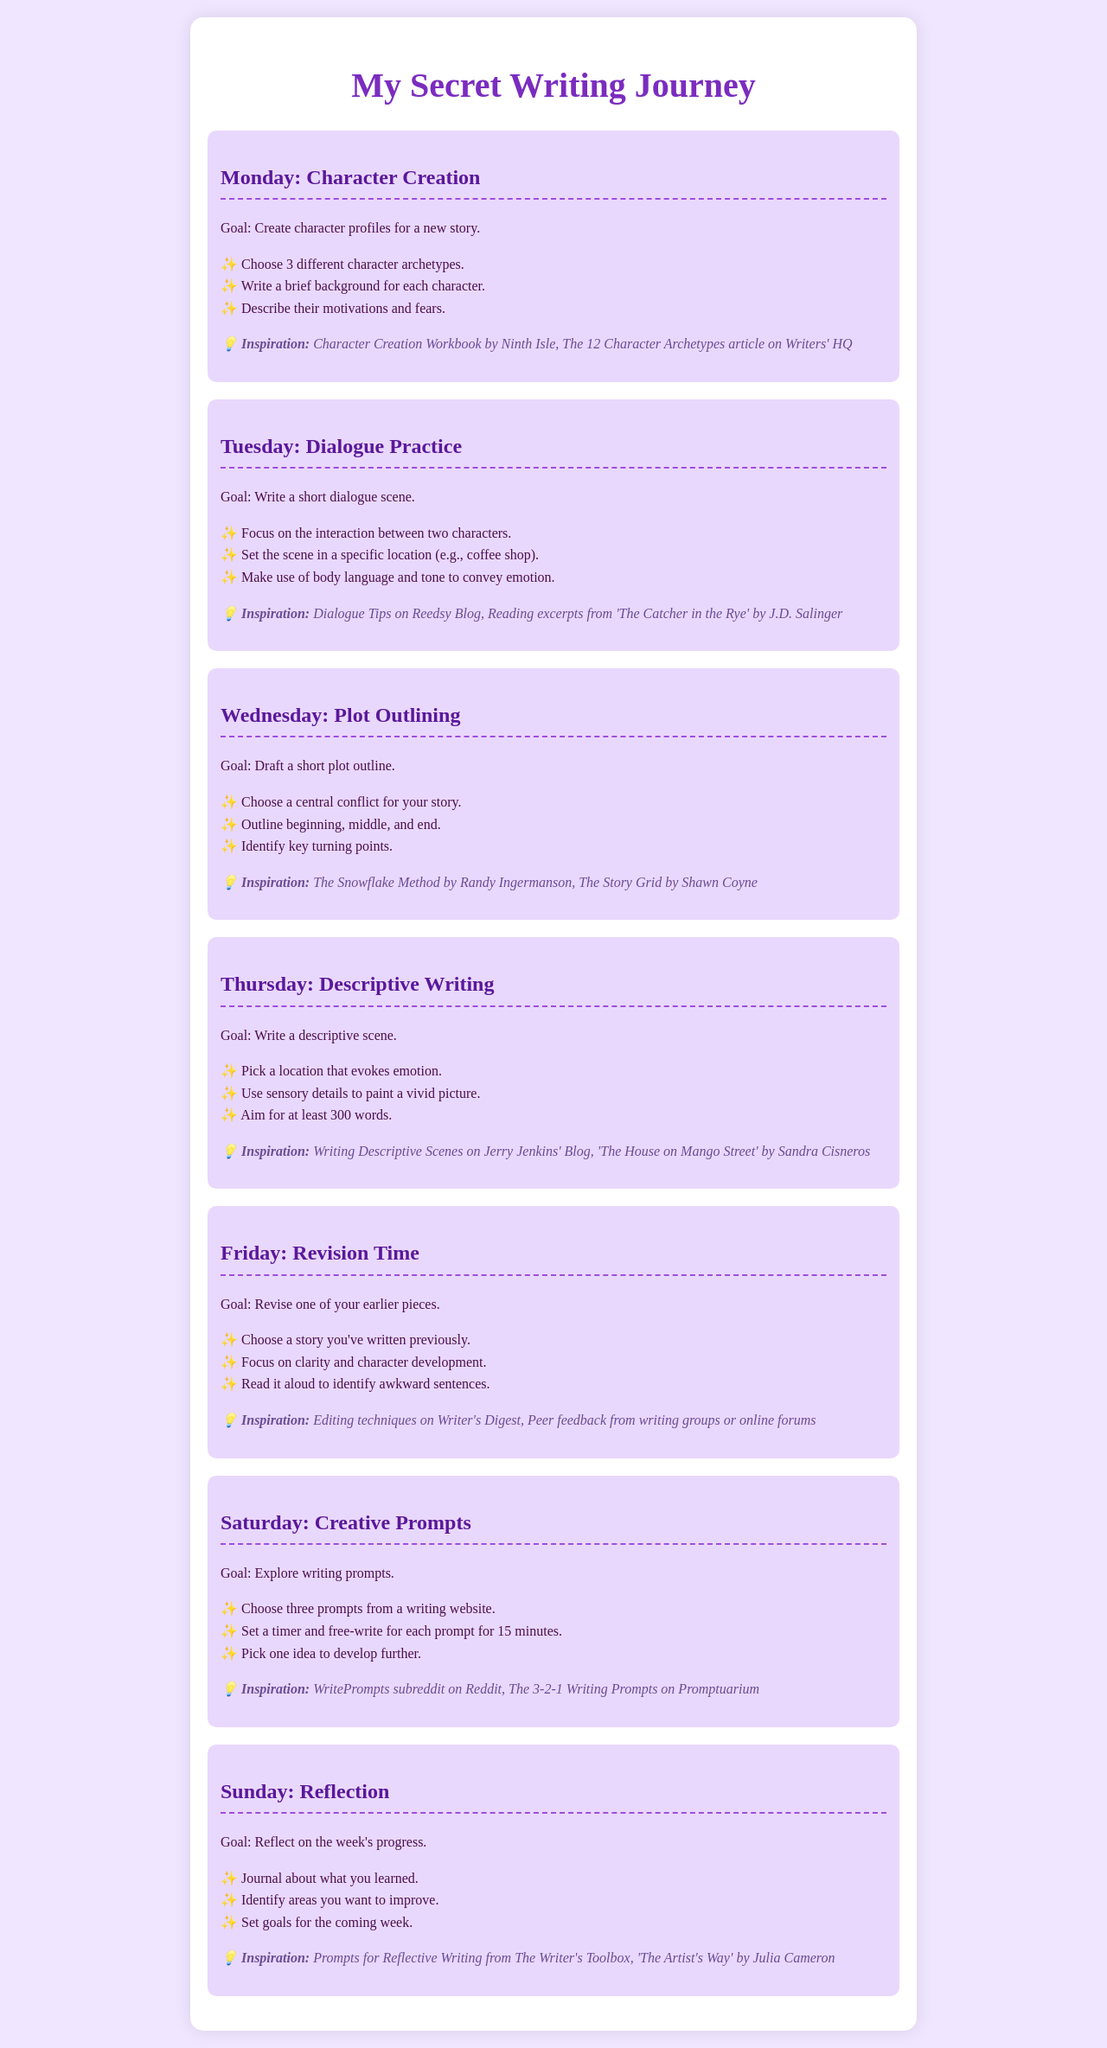What is the writing goal for Monday? The writing goal for Monday is to create character profiles for a new story.
Answer: create character profiles for a new story Who is the author of 'The Catcher in the Rye'? 'The Catcher in the Rye' is authored by J.D. Salinger.
Answer: J.D. Salinger How many character archetypes should be chosen on Monday? The document states to choose 3 different character archetypes.
Answer: 3 What should be included in the Wednesday plot outline? The Wednesday plot outline should include a central conflict, a beginning, middle, and end, and key turning points.
Answer: central conflict, beginning, middle, and end, key turning points Which day focuses on revising previous stories? Friday is the day that focuses on revising one of the earlier pieces.
Answer: Friday What type of writing activity is suggested for Saturday? The suggested activity for Saturday is to explore writing prompts.
Answer: explore writing prompts What is the total number of daily writing goals listed in the schedule? The schedule includes a total of 7 daily writing goals.
Answer: 7 What is the primary inspiration source for Thursday's writing? The primary inspiration source for Thursday is Writing Descriptive Scenes on Jerry Jenkins' Blog.
Answer: Writing Descriptive Scenes on Jerry Jenkins' Blog What should be done on Sunday regarding the week's progress? On Sunday, one should journal about what they learned and set goals for the coming week.
Answer: journal about what you learned and set goals for the coming week 